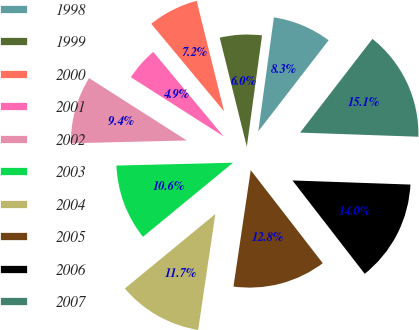Convert chart. <chart><loc_0><loc_0><loc_500><loc_500><pie_chart><fcel>1998<fcel>1999<fcel>2000<fcel>2001<fcel>2002<fcel>2003<fcel>2004<fcel>2005<fcel>2006<fcel>2007<nl><fcel>8.3%<fcel>6.04%<fcel>7.17%<fcel>4.91%<fcel>9.43%<fcel>10.57%<fcel>11.7%<fcel>12.83%<fcel>13.96%<fcel>15.09%<nl></chart> 